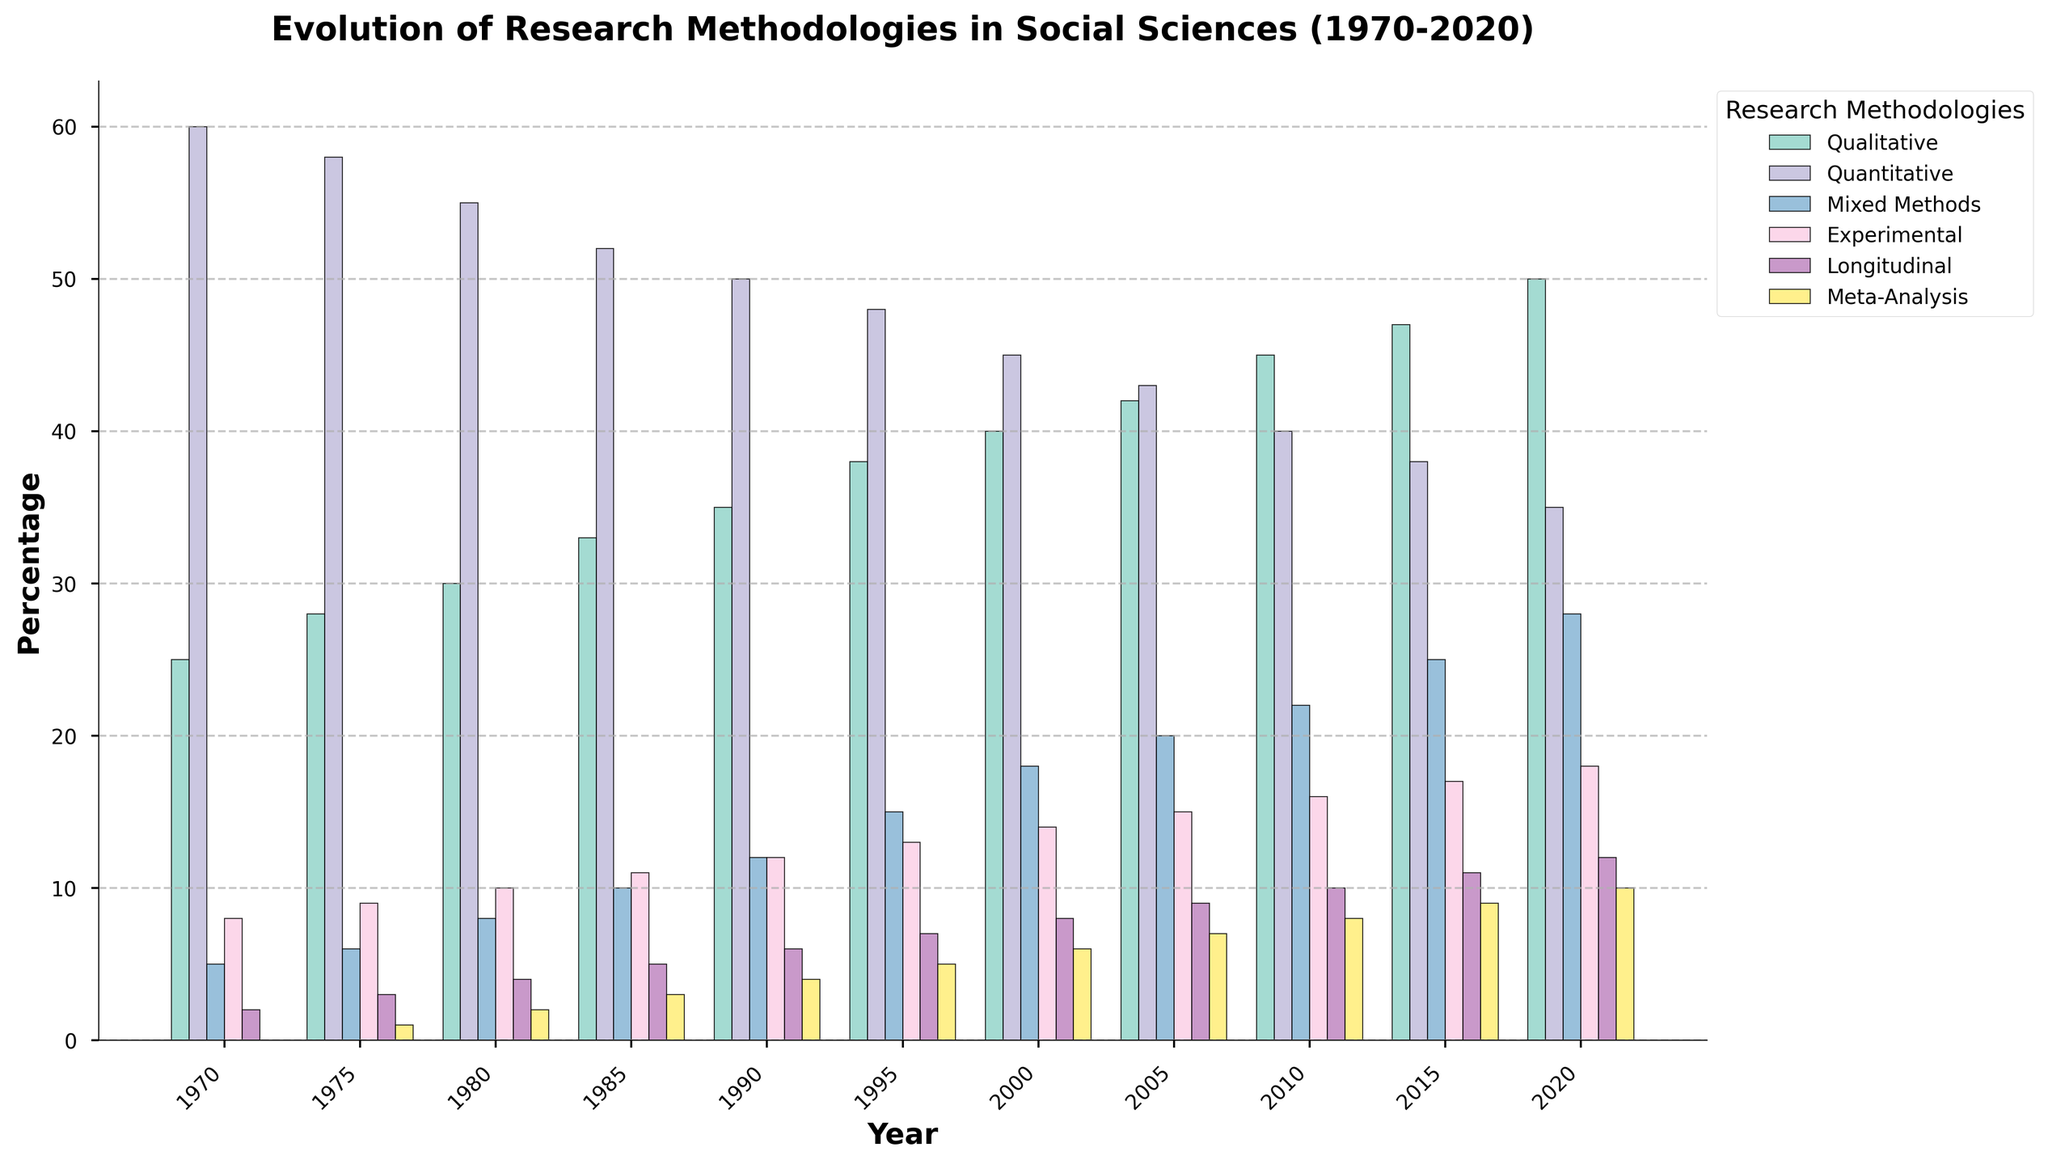What methodology had the highest percentage in 1970? Look at the bars representing 1970 and identify the tallest one. The tallest bar is for Quantitative research, which has a percentage of 60.
Answer: Quantitative How did the percentage of Mixed Methods change from 1980 to 2020? Compare the heights of the Mixed Methods bars from 1980 and 2020. In 1980, it is 8%, and in 2020, it is 28%. Subtract the 1980 value from the 2020 value to find the change: 28% - 8% = 20%.
Answer: Increased by 20% Which research methodology showed a continuous increase in percentage from 1970 to 2020? Observe the trends for each methodology over the years. Qualitative, Mixed Methods, Experimental, Longitudinal, and Meta-Analysis all show a continuous increase, while Quantitative shows a decrease.
Answer: Qualitative, Mixed Methods, Experimental, Longitudinal, Meta-Analysis By how much did the percentage of Longitudinal studies increase from 1970 to 2020? Look for the difference between the Longitudinal percentages in 1970 (2%) and 2020 (12%). Subtract the 1970 value from the 2020 value: 12% - 2% = 10%.
Answer: 10% Which two methodologies had the closest percentages in 1995? Check the 1995 bars for each methodology and compare their heights to find the two closest values. Qualitative (38%) and Quantitative (48%) are separated by 10%, while all other comparisons are greater.
Answer: Meta-Analysis & Longitudinal What is the average percentage of Experimental methodology between 1970 and 2020? Sum the percentages of Experimental methodology for all the given years and divide by the number of years: (8 + 9 + 10 + 11 + 12 + 13 + 14 + 15 + 16 + 17 + 18) / 11. The sum is 143, so the average is 143/11 ≈ 13.
Answer: 13 Which year had the largest number of methodologies exceeding 20%? Identify the years where more than one methodology exceeds 20%. In 2020, Qualitative (50%), Quantitative (35%), Mixed Methods (28%), and Experimental (18%) qualify. However, only 3 of them exceed 20%. In 2015, 4 methodologies exceed 20%: Qualitative (47%), Quantitative (38%), Mixed Methods (25%), and Experimental (17%). Therefore, 2015 had the highest number with 4.
Answer: 2015 